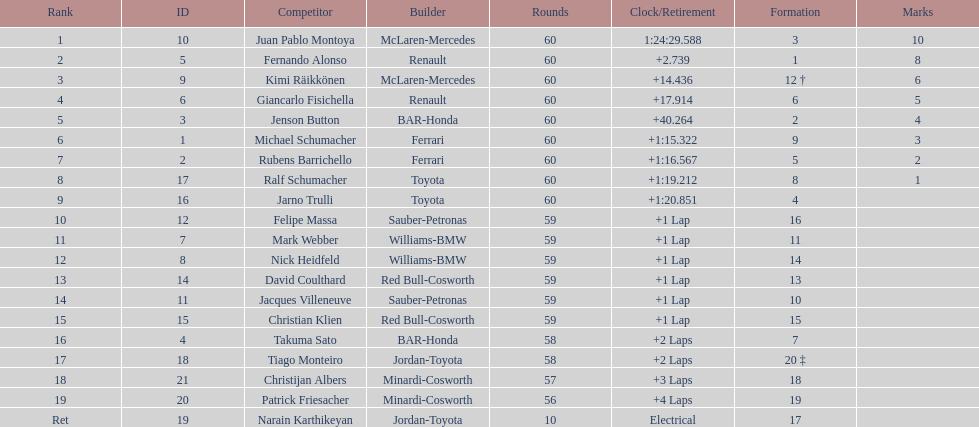How many drivers from germany? 3. 